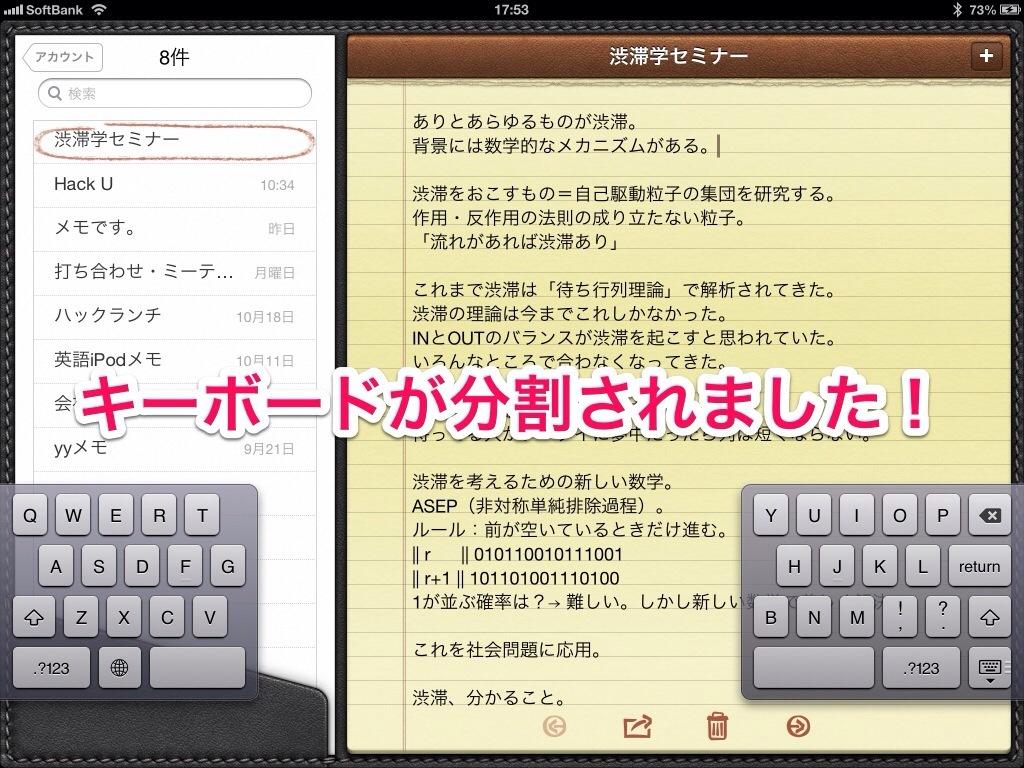What percentage of the battery is left?
Offer a very short reply. 73. Is this tablet connected to wifi?
Offer a terse response. Yes. 